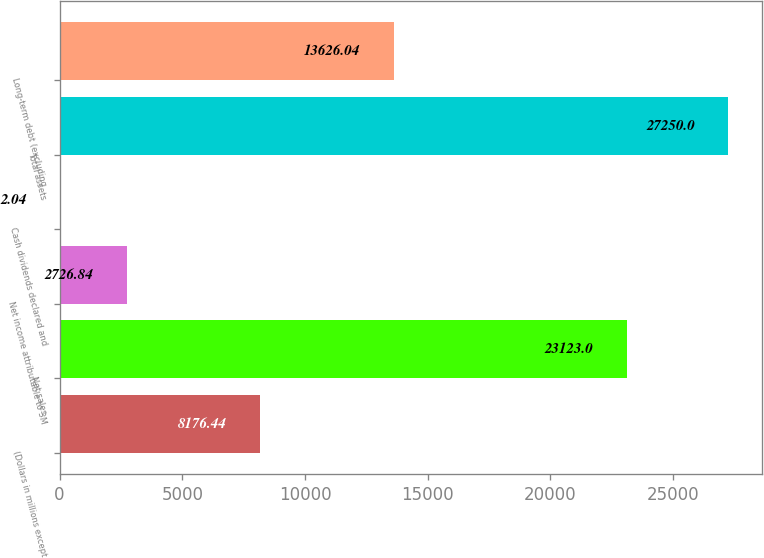<chart> <loc_0><loc_0><loc_500><loc_500><bar_chart><fcel>(Dollars in millions except<fcel>Net sales<fcel>Net income attributable to 3M<fcel>Cash dividends declared and<fcel>Total assets<fcel>Long-term debt (excluding<nl><fcel>8176.44<fcel>23123<fcel>2726.84<fcel>2.04<fcel>27250<fcel>13626<nl></chart> 